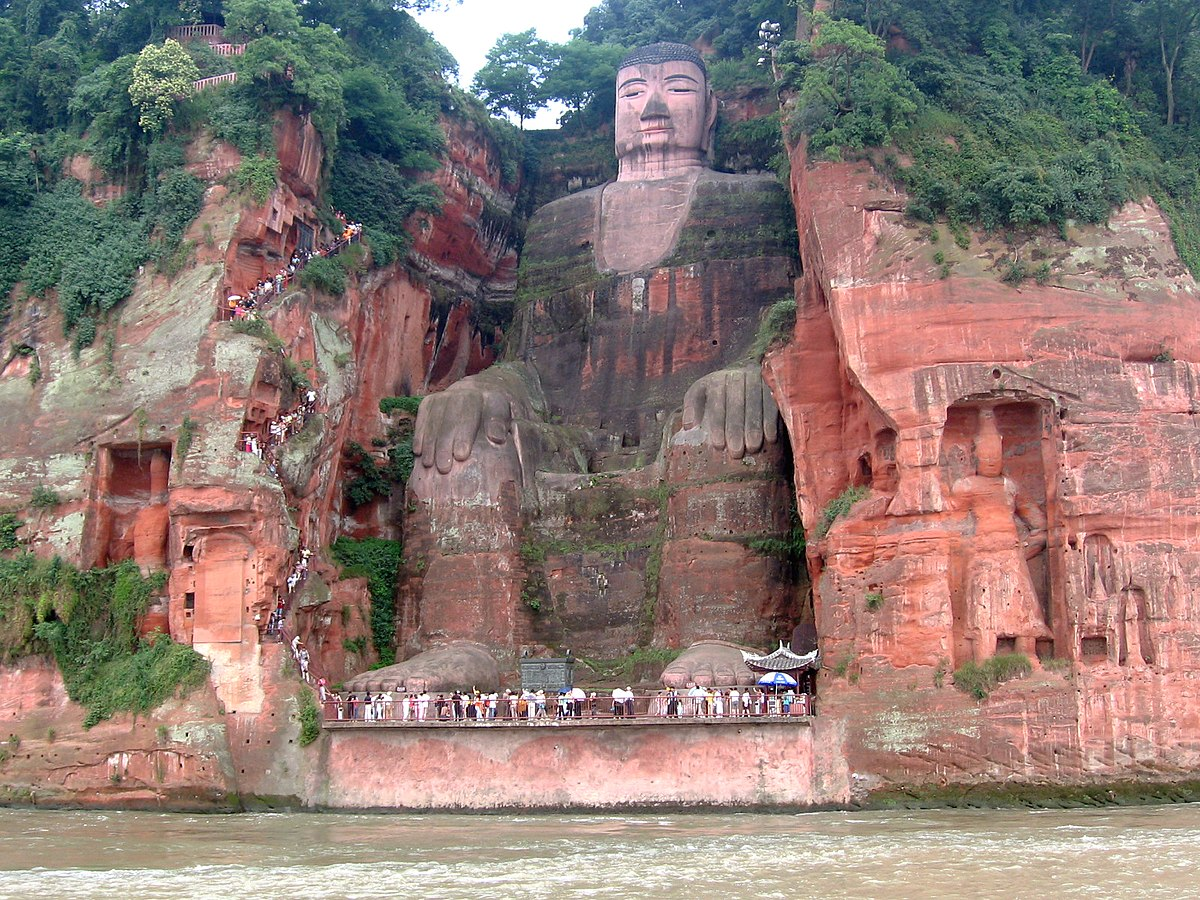What kind of challenges might visitors face when visiting this site? Visitors to the Leshan Giant Buddha may face several challenges. Due to its popularity, the site can get quite crowded, especially during peak tourist seasons. The weather can also be unpredictable, with occasional heavy rains that might affect visibility and accessibility. The paths and stairways carved into the cliff are steep and may be difficult for those with limited mobility. However, the awe-inspiring view and the spiritual ambiance of the site make the effort worthwhile. 